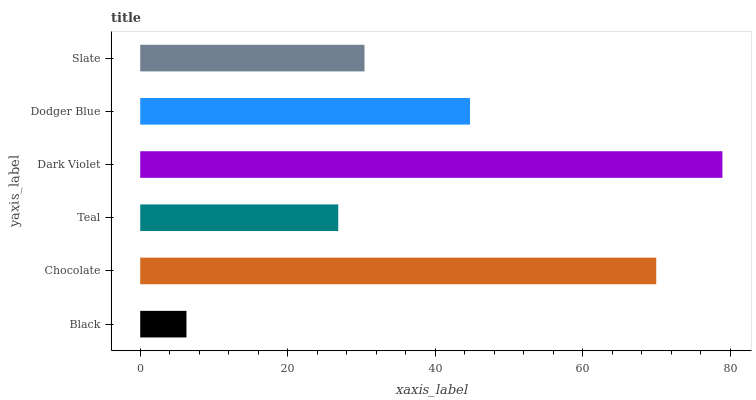Is Black the minimum?
Answer yes or no. Yes. Is Dark Violet the maximum?
Answer yes or no. Yes. Is Chocolate the minimum?
Answer yes or no. No. Is Chocolate the maximum?
Answer yes or no. No. Is Chocolate greater than Black?
Answer yes or no. Yes. Is Black less than Chocolate?
Answer yes or no. Yes. Is Black greater than Chocolate?
Answer yes or no. No. Is Chocolate less than Black?
Answer yes or no. No. Is Dodger Blue the high median?
Answer yes or no. Yes. Is Slate the low median?
Answer yes or no. Yes. Is Chocolate the high median?
Answer yes or no. No. Is Chocolate the low median?
Answer yes or no. No. 